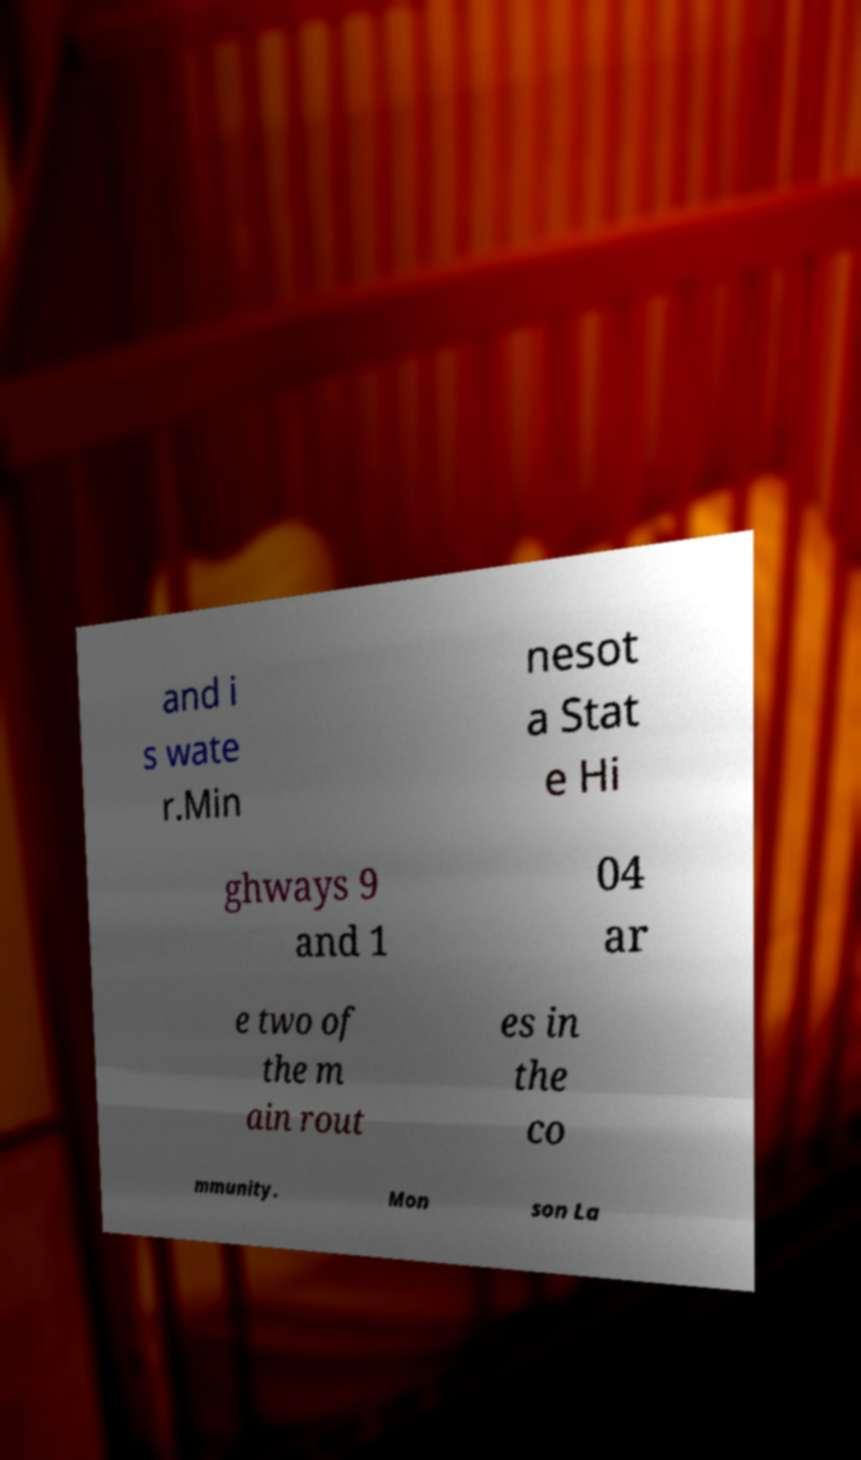Can you accurately transcribe the text from the provided image for me? and i s wate r.Min nesot a Stat e Hi ghways 9 and 1 04 ar e two of the m ain rout es in the co mmunity. Mon son La 